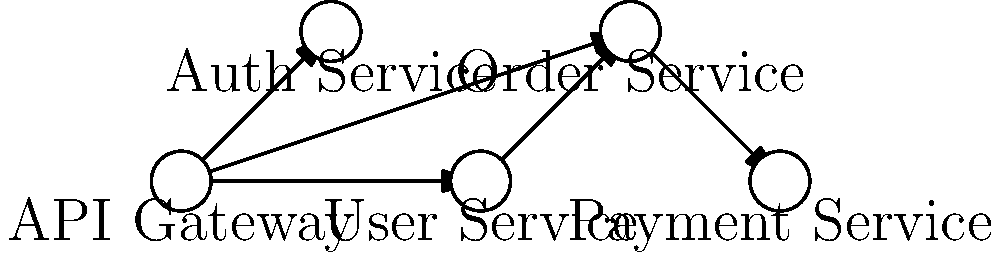In the given microservices architecture diagram, which service acts as the central point of entry for all client requests and routes them to the appropriate microservices? To determine the central point of entry for all client requests in this microservices architecture, we need to analyze the diagram step-by-step:

1. Observe the layout of the services in the diagram.
2. Identify the service that has outgoing connections to multiple other services.
3. Note that the "API Gateway" is positioned at the left-most part of the diagram.
4. Observe that the "API Gateway" has outgoing arrows to three other services: Auth Service, User Service, and Order Service.
5. Recognize that no other service in the diagram has multiple outgoing connections to different services.
6. Understand that in a typical microservices architecture, the API Gateway serves as the single entry point for all client requests.
7. The API Gateway then routes these requests to the appropriate microservices based on the request type and content.

Given these observations and understanding of microservices architecture, we can conclude that the API Gateway is the central point of entry for all client requests in this diagram.
Answer: API Gateway 